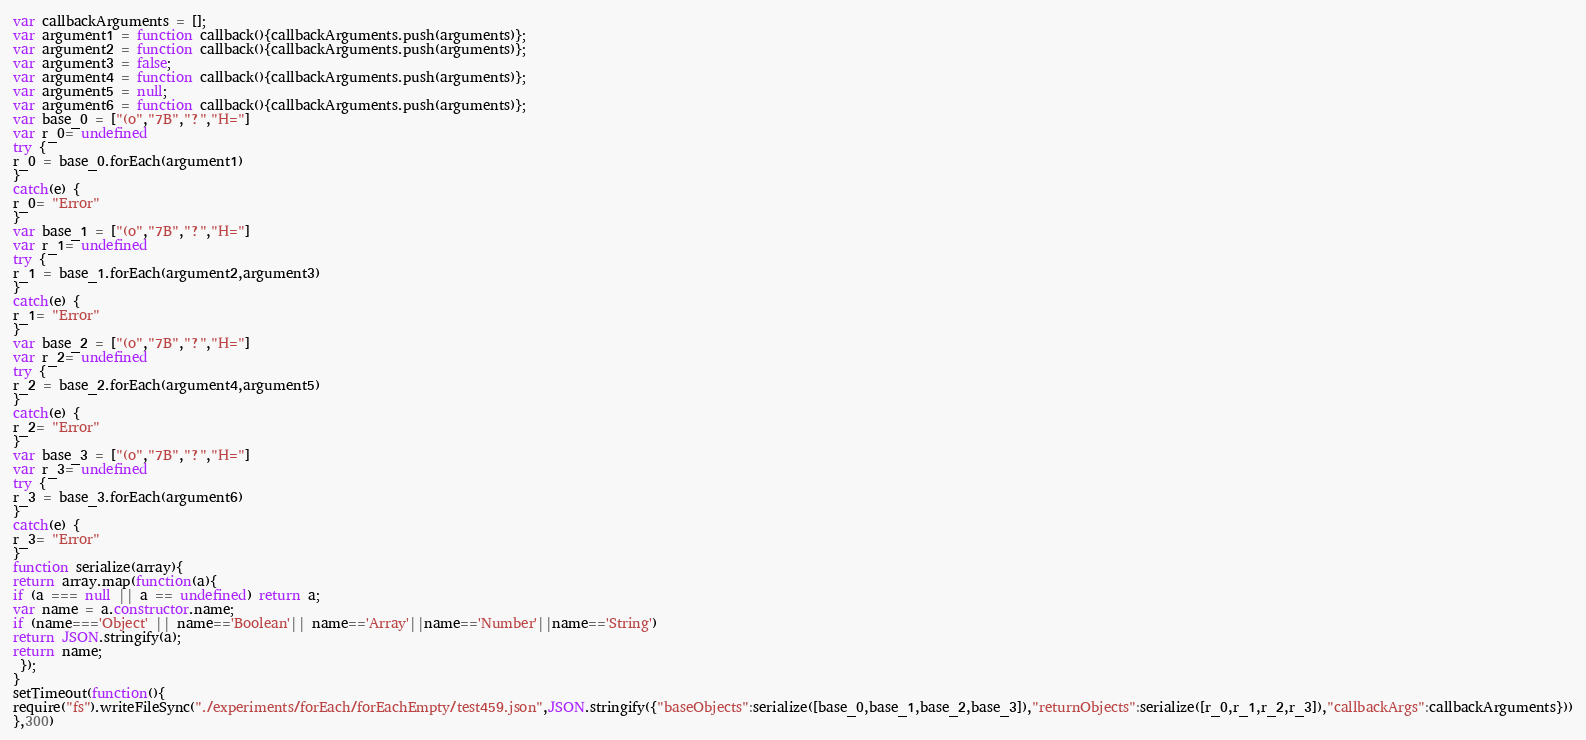Convert code to text. <code><loc_0><loc_0><loc_500><loc_500><_JavaScript_>





var callbackArguments = [];
var argument1 = function callback(){callbackArguments.push(arguments)};
var argument2 = function callback(){callbackArguments.push(arguments)};
var argument3 = false;
var argument4 = function callback(){callbackArguments.push(arguments)};
var argument5 = null;
var argument6 = function callback(){callbackArguments.push(arguments)};
var base_0 = ["(o","7B","?","H="]
var r_0= undefined
try {
r_0 = base_0.forEach(argument1)
}
catch(e) {
r_0= "Error"
}
var base_1 = ["(o","7B","?","H="]
var r_1= undefined
try {
r_1 = base_1.forEach(argument2,argument3)
}
catch(e) {
r_1= "Error"
}
var base_2 = ["(o","7B","?","H="]
var r_2= undefined
try {
r_2 = base_2.forEach(argument4,argument5)
}
catch(e) {
r_2= "Error"
}
var base_3 = ["(o","7B","?","H="]
var r_3= undefined
try {
r_3 = base_3.forEach(argument6)
}
catch(e) {
r_3= "Error"
}
function serialize(array){
return array.map(function(a){
if (a === null || a == undefined) return a;
var name = a.constructor.name;
if (name==='Object' || name=='Boolean'|| name=='Array'||name=='Number'||name=='String')
return JSON.stringify(a);
return name;
 });
}
setTimeout(function(){
require("fs").writeFileSync("./experiments/forEach/forEachEmpty/test459.json",JSON.stringify({"baseObjects":serialize([base_0,base_1,base_2,base_3]),"returnObjects":serialize([r_0,r_1,r_2,r_3]),"callbackArgs":callbackArguments}))
},300)</code> 